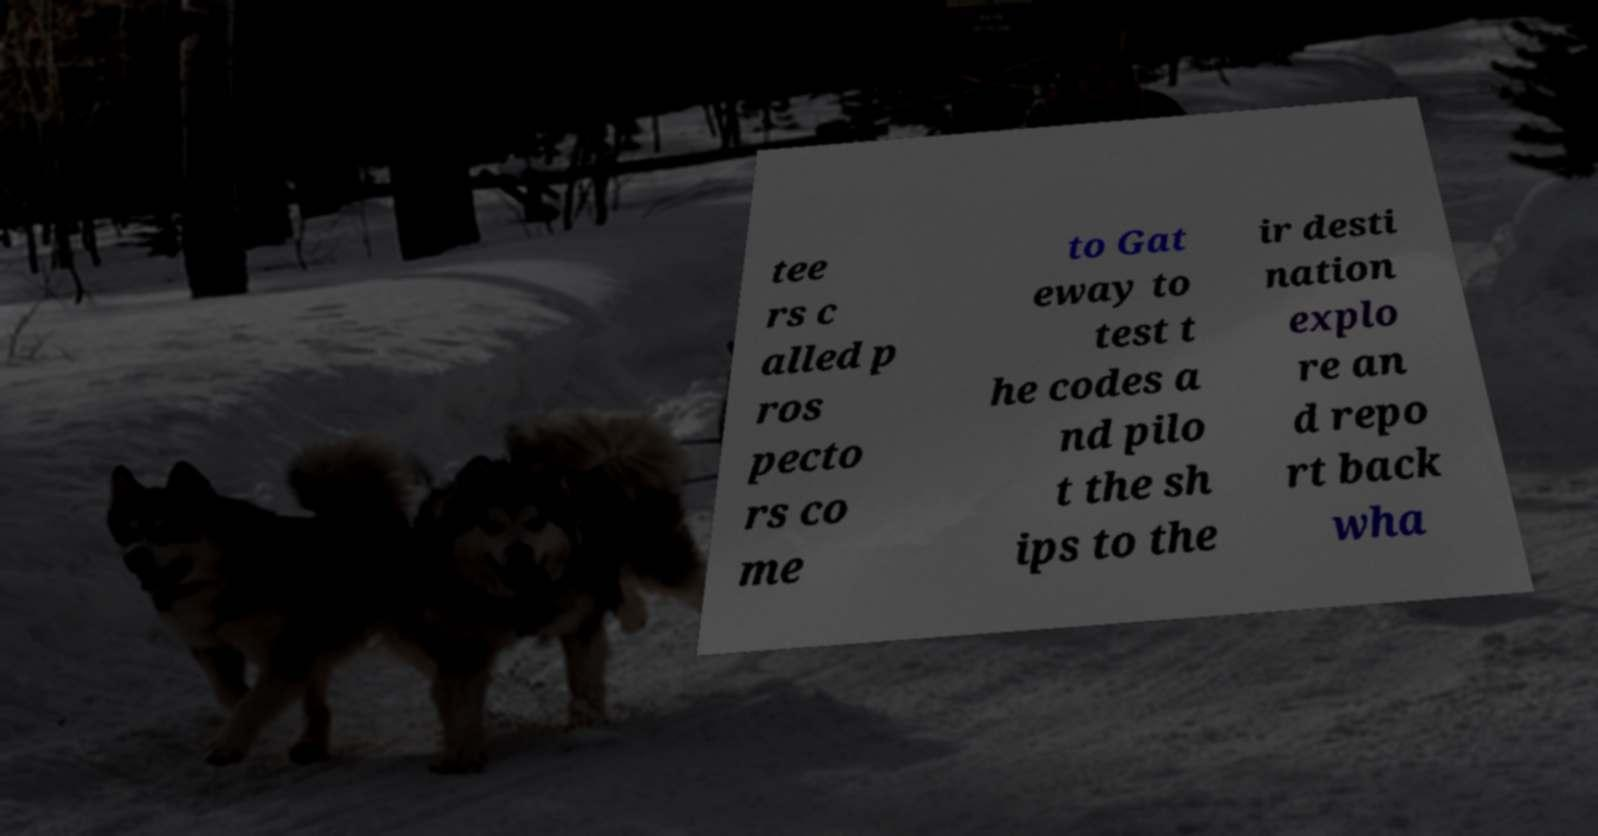Please read and relay the text visible in this image. What does it say? tee rs c alled p ros pecto rs co me to Gat eway to test t he codes a nd pilo t the sh ips to the ir desti nation explo re an d repo rt back wha 